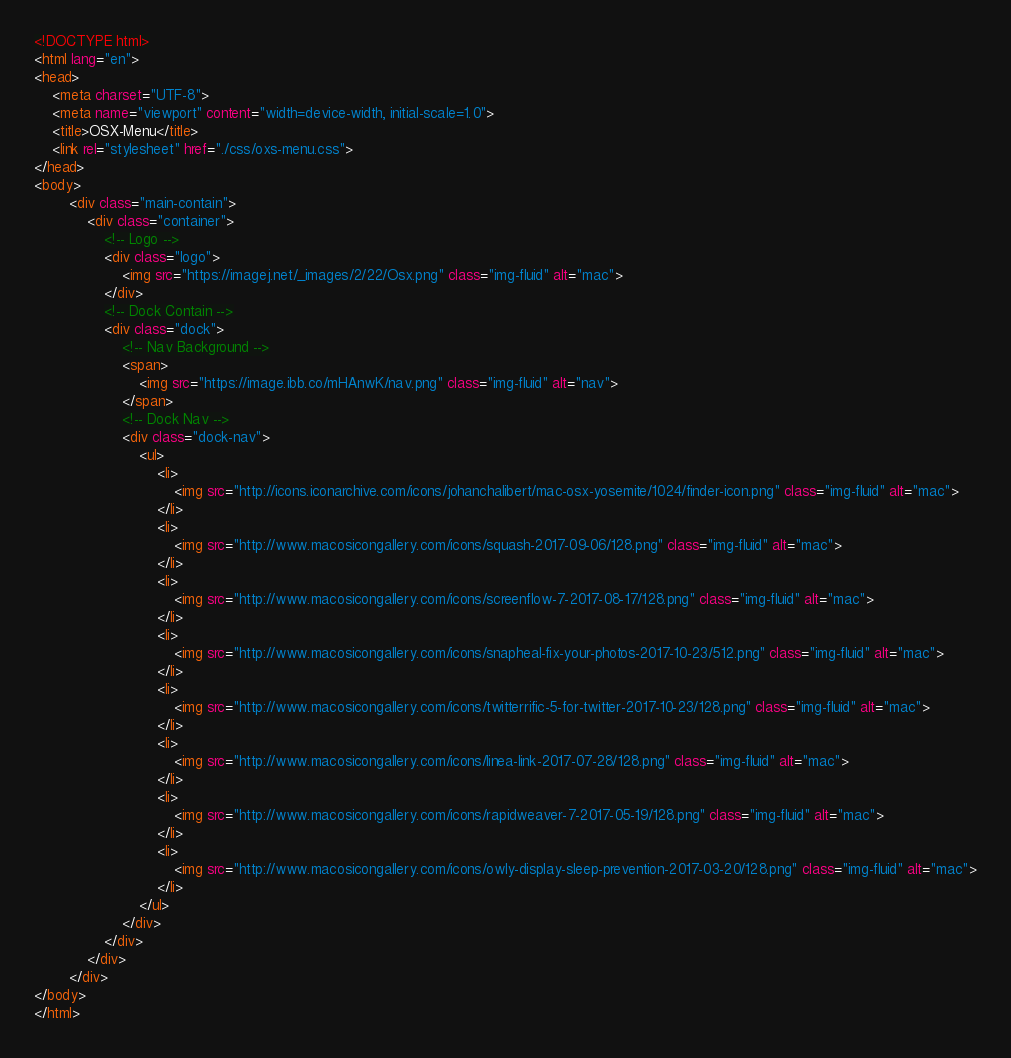<code> <loc_0><loc_0><loc_500><loc_500><_HTML_><!DOCTYPE html>
<html lang="en">
<head>
    <meta charset="UTF-8">
    <meta name="viewport" content="width=device-width, initial-scale=1.0">
    <title>OSX-Menu</title>
    <link rel="stylesheet" href="./css/oxs-menu.css">
</head>
<body>
    	<div class="main-contain">
			<div class="container">
				<!-- Logo -->
				<div class="logo">
					<img src="https://imagej.net/_images/2/22/Osx.png" class="img-fluid" alt="mac">
				</div>
				<!-- Dock Contain -->
				<div class="dock">
					<!-- Nav Background -->					
					<span>
						<img src="https://image.ibb.co/mHAnwK/nav.png" class="img-fluid" alt="nav">
					</span>
					<!-- Dock Nav -->
					<div class="dock-nav">
						<ul>							
							<li>
								<img src="http://icons.iconarchive.com/icons/johanchalibert/mac-osx-yosemite/1024/finder-icon.png" class="img-fluid" alt="mac">
							</li>							
							<li>
								<img src="http://www.macosicongallery.com/icons/squash-2017-09-06/128.png" class="img-fluid" alt="mac">
							</li>
							<li>
								<img src="http://www.macosicongallery.com/icons/screenflow-7-2017-08-17/128.png" class="img-fluid" alt="mac">
							</li>
							<li>
								<img src="http://www.macosicongallery.com/icons/snapheal-fix-your-photos-2017-10-23/512.png" class="img-fluid" alt="mac">
							</li>
							<li>
								<img src="http://www.macosicongallery.com/icons/twitterrific-5-for-twitter-2017-10-23/128.png" class="img-fluid" alt="mac">
							</li>
							<li>
								<img src="http://www.macosicongallery.com/icons/linea-link-2017-07-28/128.png" class="img-fluid" alt="mac">
							</li>
							<li>
								<img src="http://www.macosicongallery.com/icons/rapidweaver-7-2017-05-19/128.png" class="img-fluid" alt="mac">
							</li>
							<li>
								<img src="http://www.macosicongallery.com/icons/owly-display-sleep-prevention-2017-03-20/128.png" class="img-fluid" alt="mac">
							</li>
						</ul>
					</div>
				</div>
			</div>			
		</div>
</body>
</html>


</code> 